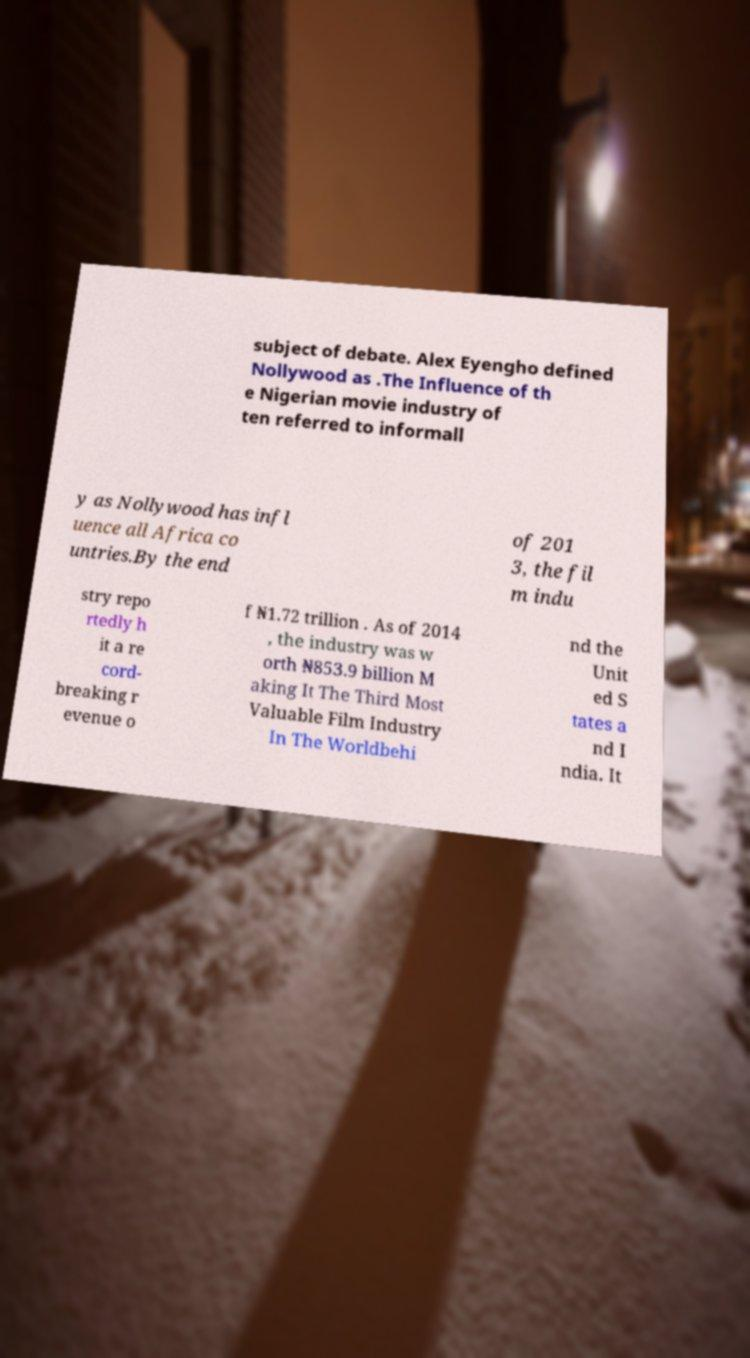Can you read and provide the text displayed in the image?This photo seems to have some interesting text. Can you extract and type it out for me? subject of debate. Alex Eyengho defined Nollywood as .The Influence of th e Nigerian movie industry of ten referred to informall y as Nollywood has infl uence all Africa co untries.By the end of 201 3, the fil m indu stry repo rtedly h it a re cord- breaking r evenue o f ₦1.72 trillion . As of 2014 , the industry was w orth ₦853.9 billion M aking It The Third Most Valuable Film Industry In The Worldbehi nd the Unit ed S tates a nd I ndia. It 